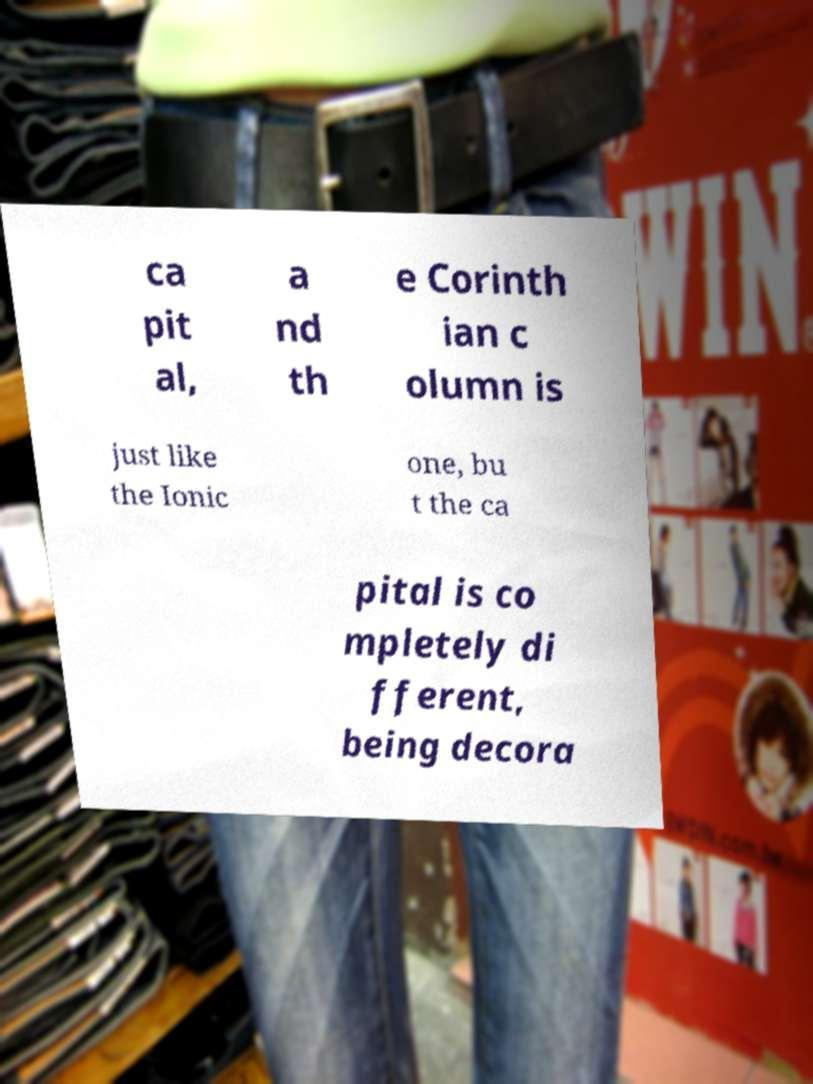I need the written content from this picture converted into text. Can you do that? ca pit al, a nd th e Corinth ian c olumn is just like the Ionic one, bu t the ca pital is co mpletely di fferent, being decora 